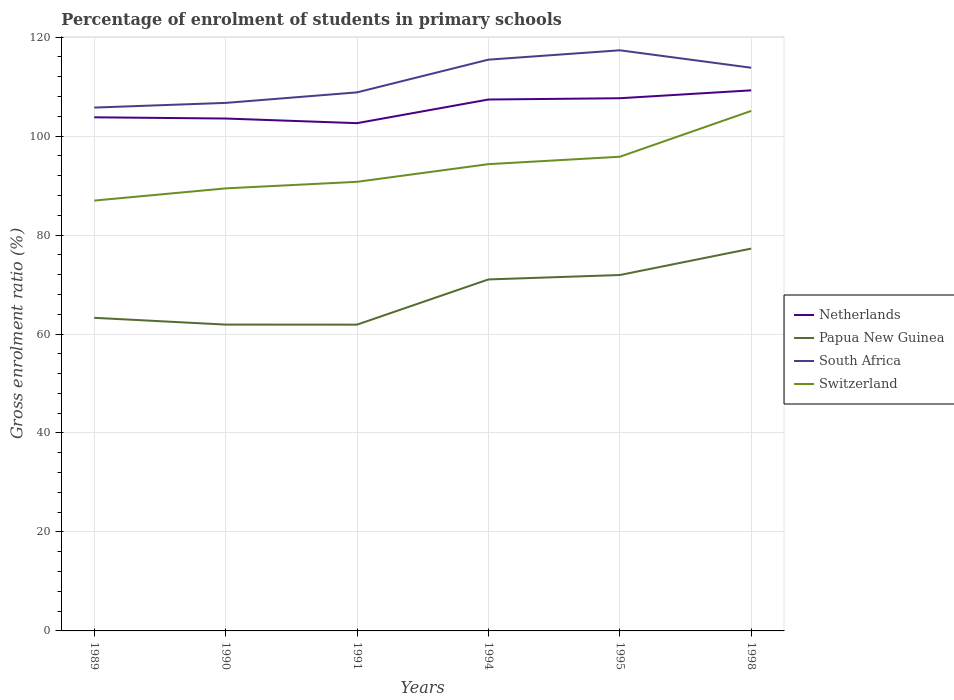How many different coloured lines are there?
Keep it short and to the point. 4. Is the number of lines equal to the number of legend labels?
Offer a very short reply. Yes. Across all years, what is the maximum percentage of students enrolled in primary schools in Switzerland?
Provide a short and direct response. 86.97. What is the total percentage of students enrolled in primary schools in Netherlands in the graph?
Ensure brevity in your answer.  0.25. What is the difference between the highest and the second highest percentage of students enrolled in primary schools in South Africa?
Make the answer very short. 11.58. What is the difference between the highest and the lowest percentage of students enrolled in primary schools in Switzerland?
Make the answer very short. 3. How many years are there in the graph?
Give a very brief answer. 6. Where does the legend appear in the graph?
Provide a short and direct response. Center right. How many legend labels are there?
Ensure brevity in your answer.  4. What is the title of the graph?
Your answer should be compact. Percentage of enrolment of students in primary schools. Does "Netherlands" appear as one of the legend labels in the graph?
Give a very brief answer. Yes. What is the label or title of the X-axis?
Keep it short and to the point. Years. What is the Gross enrolment ratio (%) of Netherlands in 1989?
Give a very brief answer. 103.8. What is the Gross enrolment ratio (%) of Papua New Guinea in 1989?
Offer a terse response. 63.28. What is the Gross enrolment ratio (%) in South Africa in 1989?
Make the answer very short. 105.76. What is the Gross enrolment ratio (%) in Switzerland in 1989?
Your answer should be compact. 86.97. What is the Gross enrolment ratio (%) of Netherlands in 1990?
Give a very brief answer. 103.55. What is the Gross enrolment ratio (%) in Papua New Guinea in 1990?
Your answer should be very brief. 61.91. What is the Gross enrolment ratio (%) of South Africa in 1990?
Provide a succinct answer. 106.71. What is the Gross enrolment ratio (%) in Switzerland in 1990?
Your response must be concise. 89.43. What is the Gross enrolment ratio (%) in Netherlands in 1991?
Provide a short and direct response. 102.61. What is the Gross enrolment ratio (%) of Papua New Guinea in 1991?
Provide a short and direct response. 61.9. What is the Gross enrolment ratio (%) in South Africa in 1991?
Provide a succinct answer. 108.83. What is the Gross enrolment ratio (%) of Switzerland in 1991?
Provide a short and direct response. 90.76. What is the Gross enrolment ratio (%) in Netherlands in 1994?
Your answer should be compact. 107.39. What is the Gross enrolment ratio (%) in Papua New Guinea in 1994?
Offer a terse response. 71.03. What is the Gross enrolment ratio (%) in South Africa in 1994?
Ensure brevity in your answer.  115.45. What is the Gross enrolment ratio (%) of Switzerland in 1994?
Your answer should be very brief. 94.33. What is the Gross enrolment ratio (%) in Netherlands in 1995?
Provide a succinct answer. 107.65. What is the Gross enrolment ratio (%) of Papua New Guinea in 1995?
Give a very brief answer. 71.92. What is the Gross enrolment ratio (%) in South Africa in 1995?
Provide a succinct answer. 117.34. What is the Gross enrolment ratio (%) of Switzerland in 1995?
Provide a short and direct response. 95.83. What is the Gross enrolment ratio (%) in Netherlands in 1998?
Provide a short and direct response. 109.25. What is the Gross enrolment ratio (%) in Papua New Guinea in 1998?
Offer a terse response. 77.26. What is the Gross enrolment ratio (%) in South Africa in 1998?
Keep it short and to the point. 113.82. What is the Gross enrolment ratio (%) of Switzerland in 1998?
Your answer should be very brief. 105.09. Across all years, what is the maximum Gross enrolment ratio (%) of Netherlands?
Make the answer very short. 109.25. Across all years, what is the maximum Gross enrolment ratio (%) in Papua New Guinea?
Provide a short and direct response. 77.26. Across all years, what is the maximum Gross enrolment ratio (%) in South Africa?
Your answer should be very brief. 117.34. Across all years, what is the maximum Gross enrolment ratio (%) of Switzerland?
Offer a terse response. 105.09. Across all years, what is the minimum Gross enrolment ratio (%) in Netherlands?
Ensure brevity in your answer.  102.61. Across all years, what is the minimum Gross enrolment ratio (%) in Papua New Guinea?
Your answer should be very brief. 61.9. Across all years, what is the minimum Gross enrolment ratio (%) in South Africa?
Offer a very short reply. 105.76. Across all years, what is the minimum Gross enrolment ratio (%) in Switzerland?
Make the answer very short. 86.97. What is the total Gross enrolment ratio (%) in Netherlands in the graph?
Provide a short and direct response. 634.25. What is the total Gross enrolment ratio (%) of Papua New Guinea in the graph?
Your response must be concise. 407.3. What is the total Gross enrolment ratio (%) in South Africa in the graph?
Offer a very short reply. 667.91. What is the total Gross enrolment ratio (%) of Switzerland in the graph?
Give a very brief answer. 562.41. What is the difference between the Gross enrolment ratio (%) of Netherlands in 1989 and that in 1990?
Keep it short and to the point. 0.25. What is the difference between the Gross enrolment ratio (%) in Papua New Guinea in 1989 and that in 1990?
Offer a very short reply. 1.37. What is the difference between the Gross enrolment ratio (%) of South Africa in 1989 and that in 1990?
Your answer should be very brief. -0.94. What is the difference between the Gross enrolment ratio (%) of Switzerland in 1989 and that in 1990?
Offer a very short reply. -2.47. What is the difference between the Gross enrolment ratio (%) of Netherlands in 1989 and that in 1991?
Your answer should be very brief. 1.18. What is the difference between the Gross enrolment ratio (%) in Papua New Guinea in 1989 and that in 1991?
Provide a short and direct response. 1.38. What is the difference between the Gross enrolment ratio (%) of South Africa in 1989 and that in 1991?
Your response must be concise. -3.07. What is the difference between the Gross enrolment ratio (%) in Switzerland in 1989 and that in 1991?
Your answer should be compact. -3.79. What is the difference between the Gross enrolment ratio (%) of Netherlands in 1989 and that in 1994?
Provide a succinct answer. -3.6. What is the difference between the Gross enrolment ratio (%) of Papua New Guinea in 1989 and that in 1994?
Offer a very short reply. -7.76. What is the difference between the Gross enrolment ratio (%) in South Africa in 1989 and that in 1994?
Offer a very short reply. -9.68. What is the difference between the Gross enrolment ratio (%) of Switzerland in 1989 and that in 1994?
Your response must be concise. -7.36. What is the difference between the Gross enrolment ratio (%) in Netherlands in 1989 and that in 1995?
Offer a very short reply. -3.85. What is the difference between the Gross enrolment ratio (%) of Papua New Guinea in 1989 and that in 1995?
Ensure brevity in your answer.  -8.65. What is the difference between the Gross enrolment ratio (%) of South Africa in 1989 and that in 1995?
Keep it short and to the point. -11.58. What is the difference between the Gross enrolment ratio (%) of Switzerland in 1989 and that in 1995?
Provide a short and direct response. -8.86. What is the difference between the Gross enrolment ratio (%) in Netherlands in 1989 and that in 1998?
Make the answer very short. -5.45. What is the difference between the Gross enrolment ratio (%) of Papua New Guinea in 1989 and that in 1998?
Provide a short and direct response. -13.99. What is the difference between the Gross enrolment ratio (%) of South Africa in 1989 and that in 1998?
Keep it short and to the point. -8.05. What is the difference between the Gross enrolment ratio (%) in Switzerland in 1989 and that in 1998?
Keep it short and to the point. -18.12. What is the difference between the Gross enrolment ratio (%) of Netherlands in 1990 and that in 1991?
Make the answer very short. 0.93. What is the difference between the Gross enrolment ratio (%) of Papua New Guinea in 1990 and that in 1991?
Make the answer very short. 0.01. What is the difference between the Gross enrolment ratio (%) in South Africa in 1990 and that in 1991?
Make the answer very short. -2.13. What is the difference between the Gross enrolment ratio (%) of Switzerland in 1990 and that in 1991?
Offer a very short reply. -1.33. What is the difference between the Gross enrolment ratio (%) of Netherlands in 1990 and that in 1994?
Keep it short and to the point. -3.85. What is the difference between the Gross enrolment ratio (%) in Papua New Guinea in 1990 and that in 1994?
Offer a very short reply. -9.13. What is the difference between the Gross enrolment ratio (%) of South Africa in 1990 and that in 1994?
Provide a short and direct response. -8.74. What is the difference between the Gross enrolment ratio (%) in Switzerland in 1990 and that in 1994?
Offer a terse response. -4.9. What is the difference between the Gross enrolment ratio (%) in Netherlands in 1990 and that in 1995?
Keep it short and to the point. -4.1. What is the difference between the Gross enrolment ratio (%) of Papua New Guinea in 1990 and that in 1995?
Provide a succinct answer. -10.02. What is the difference between the Gross enrolment ratio (%) of South Africa in 1990 and that in 1995?
Offer a very short reply. -10.63. What is the difference between the Gross enrolment ratio (%) in Switzerland in 1990 and that in 1995?
Your response must be concise. -6.39. What is the difference between the Gross enrolment ratio (%) in Netherlands in 1990 and that in 1998?
Make the answer very short. -5.7. What is the difference between the Gross enrolment ratio (%) in Papua New Guinea in 1990 and that in 1998?
Your answer should be compact. -15.36. What is the difference between the Gross enrolment ratio (%) in South Africa in 1990 and that in 1998?
Offer a terse response. -7.11. What is the difference between the Gross enrolment ratio (%) in Switzerland in 1990 and that in 1998?
Your answer should be very brief. -15.65. What is the difference between the Gross enrolment ratio (%) of Netherlands in 1991 and that in 1994?
Make the answer very short. -4.78. What is the difference between the Gross enrolment ratio (%) in Papua New Guinea in 1991 and that in 1994?
Give a very brief answer. -9.14. What is the difference between the Gross enrolment ratio (%) in South Africa in 1991 and that in 1994?
Your answer should be compact. -6.61. What is the difference between the Gross enrolment ratio (%) in Switzerland in 1991 and that in 1994?
Provide a succinct answer. -3.57. What is the difference between the Gross enrolment ratio (%) of Netherlands in 1991 and that in 1995?
Provide a succinct answer. -5.04. What is the difference between the Gross enrolment ratio (%) in Papua New Guinea in 1991 and that in 1995?
Make the answer very short. -10.03. What is the difference between the Gross enrolment ratio (%) in South Africa in 1991 and that in 1995?
Keep it short and to the point. -8.51. What is the difference between the Gross enrolment ratio (%) of Switzerland in 1991 and that in 1995?
Offer a very short reply. -5.06. What is the difference between the Gross enrolment ratio (%) of Netherlands in 1991 and that in 1998?
Your answer should be compact. -6.63. What is the difference between the Gross enrolment ratio (%) of Papua New Guinea in 1991 and that in 1998?
Ensure brevity in your answer.  -15.37. What is the difference between the Gross enrolment ratio (%) of South Africa in 1991 and that in 1998?
Provide a succinct answer. -4.98. What is the difference between the Gross enrolment ratio (%) of Switzerland in 1991 and that in 1998?
Make the answer very short. -14.33. What is the difference between the Gross enrolment ratio (%) in Netherlands in 1994 and that in 1995?
Give a very brief answer. -0.26. What is the difference between the Gross enrolment ratio (%) in Papua New Guinea in 1994 and that in 1995?
Make the answer very short. -0.89. What is the difference between the Gross enrolment ratio (%) of South Africa in 1994 and that in 1995?
Your answer should be very brief. -1.89. What is the difference between the Gross enrolment ratio (%) of Switzerland in 1994 and that in 1995?
Offer a very short reply. -1.49. What is the difference between the Gross enrolment ratio (%) of Netherlands in 1994 and that in 1998?
Ensure brevity in your answer.  -1.85. What is the difference between the Gross enrolment ratio (%) of Papua New Guinea in 1994 and that in 1998?
Provide a succinct answer. -6.23. What is the difference between the Gross enrolment ratio (%) of South Africa in 1994 and that in 1998?
Give a very brief answer. 1.63. What is the difference between the Gross enrolment ratio (%) in Switzerland in 1994 and that in 1998?
Your answer should be compact. -10.76. What is the difference between the Gross enrolment ratio (%) in Netherlands in 1995 and that in 1998?
Offer a very short reply. -1.59. What is the difference between the Gross enrolment ratio (%) of Papua New Guinea in 1995 and that in 1998?
Your response must be concise. -5.34. What is the difference between the Gross enrolment ratio (%) of South Africa in 1995 and that in 1998?
Ensure brevity in your answer.  3.52. What is the difference between the Gross enrolment ratio (%) in Switzerland in 1995 and that in 1998?
Ensure brevity in your answer.  -9.26. What is the difference between the Gross enrolment ratio (%) of Netherlands in 1989 and the Gross enrolment ratio (%) of Papua New Guinea in 1990?
Offer a terse response. 41.89. What is the difference between the Gross enrolment ratio (%) in Netherlands in 1989 and the Gross enrolment ratio (%) in South Africa in 1990?
Your response must be concise. -2.91. What is the difference between the Gross enrolment ratio (%) in Netherlands in 1989 and the Gross enrolment ratio (%) in Switzerland in 1990?
Offer a terse response. 14.36. What is the difference between the Gross enrolment ratio (%) of Papua New Guinea in 1989 and the Gross enrolment ratio (%) of South Africa in 1990?
Keep it short and to the point. -43.43. What is the difference between the Gross enrolment ratio (%) of Papua New Guinea in 1989 and the Gross enrolment ratio (%) of Switzerland in 1990?
Give a very brief answer. -26.16. What is the difference between the Gross enrolment ratio (%) of South Africa in 1989 and the Gross enrolment ratio (%) of Switzerland in 1990?
Your answer should be compact. 16.33. What is the difference between the Gross enrolment ratio (%) in Netherlands in 1989 and the Gross enrolment ratio (%) in Papua New Guinea in 1991?
Your answer should be compact. 41.9. What is the difference between the Gross enrolment ratio (%) of Netherlands in 1989 and the Gross enrolment ratio (%) of South Africa in 1991?
Your response must be concise. -5.04. What is the difference between the Gross enrolment ratio (%) of Netherlands in 1989 and the Gross enrolment ratio (%) of Switzerland in 1991?
Ensure brevity in your answer.  13.04. What is the difference between the Gross enrolment ratio (%) of Papua New Guinea in 1989 and the Gross enrolment ratio (%) of South Africa in 1991?
Keep it short and to the point. -45.56. What is the difference between the Gross enrolment ratio (%) of Papua New Guinea in 1989 and the Gross enrolment ratio (%) of Switzerland in 1991?
Provide a short and direct response. -27.48. What is the difference between the Gross enrolment ratio (%) in South Africa in 1989 and the Gross enrolment ratio (%) in Switzerland in 1991?
Offer a very short reply. 15. What is the difference between the Gross enrolment ratio (%) in Netherlands in 1989 and the Gross enrolment ratio (%) in Papua New Guinea in 1994?
Give a very brief answer. 32.76. What is the difference between the Gross enrolment ratio (%) of Netherlands in 1989 and the Gross enrolment ratio (%) of South Africa in 1994?
Your response must be concise. -11.65. What is the difference between the Gross enrolment ratio (%) in Netherlands in 1989 and the Gross enrolment ratio (%) in Switzerland in 1994?
Ensure brevity in your answer.  9.47. What is the difference between the Gross enrolment ratio (%) in Papua New Guinea in 1989 and the Gross enrolment ratio (%) in South Africa in 1994?
Provide a succinct answer. -52.17. What is the difference between the Gross enrolment ratio (%) in Papua New Guinea in 1989 and the Gross enrolment ratio (%) in Switzerland in 1994?
Provide a succinct answer. -31.05. What is the difference between the Gross enrolment ratio (%) of South Africa in 1989 and the Gross enrolment ratio (%) of Switzerland in 1994?
Provide a short and direct response. 11.43. What is the difference between the Gross enrolment ratio (%) of Netherlands in 1989 and the Gross enrolment ratio (%) of Papua New Guinea in 1995?
Your answer should be very brief. 31.87. What is the difference between the Gross enrolment ratio (%) in Netherlands in 1989 and the Gross enrolment ratio (%) in South Africa in 1995?
Ensure brevity in your answer.  -13.54. What is the difference between the Gross enrolment ratio (%) in Netherlands in 1989 and the Gross enrolment ratio (%) in Switzerland in 1995?
Provide a succinct answer. 7.97. What is the difference between the Gross enrolment ratio (%) in Papua New Guinea in 1989 and the Gross enrolment ratio (%) in South Africa in 1995?
Offer a terse response. -54.06. What is the difference between the Gross enrolment ratio (%) in Papua New Guinea in 1989 and the Gross enrolment ratio (%) in Switzerland in 1995?
Keep it short and to the point. -32.55. What is the difference between the Gross enrolment ratio (%) in South Africa in 1989 and the Gross enrolment ratio (%) in Switzerland in 1995?
Your answer should be very brief. 9.94. What is the difference between the Gross enrolment ratio (%) of Netherlands in 1989 and the Gross enrolment ratio (%) of Papua New Guinea in 1998?
Provide a succinct answer. 26.53. What is the difference between the Gross enrolment ratio (%) of Netherlands in 1989 and the Gross enrolment ratio (%) of South Africa in 1998?
Your answer should be very brief. -10.02. What is the difference between the Gross enrolment ratio (%) in Netherlands in 1989 and the Gross enrolment ratio (%) in Switzerland in 1998?
Your response must be concise. -1.29. What is the difference between the Gross enrolment ratio (%) of Papua New Guinea in 1989 and the Gross enrolment ratio (%) of South Africa in 1998?
Give a very brief answer. -50.54. What is the difference between the Gross enrolment ratio (%) of Papua New Guinea in 1989 and the Gross enrolment ratio (%) of Switzerland in 1998?
Your response must be concise. -41.81. What is the difference between the Gross enrolment ratio (%) of South Africa in 1989 and the Gross enrolment ratio (%) of Switzerland in 1998?
Ensure brevity in your answer.  0.68. What is the difference between the Gross enrolment ratio (%) in Netherlands in 1990 and the Gross enrolment ratio (%) in Papua New Guinea in 1991?
Your response must be concise. 41.65. What is the difference between the Gross enrolment ratio (%) in Netherlands in 1990 and the Gross enrolment ratio (%) in South Africa in 1991?
Offer a terse response. -5.29. What is the difference between the Gross enrolment ratio (%) of Netherlands in 1990 and the Gross enrolment ratio (%) of Switzerland in 1991?
Provide a short and direct response. 12.79. What is the difference between the Gross enrolment ratio (%) of Papua New Guinea in 1990 and the Gross enrolment ratio (%) of South Africa in 1991?
Ensure brevity in your answer.  -46.93. What is the difference between the Gross enrolment ratio (%) in Papua New Guinea in 1990 and the Gross enrolment ratio (%) in Switzerland in 1991?
Offer a terse response. -28.85. What is the difference between the Gross enrolment ratio (%) of South Africa in 1990 and the Gross enrolment ratio (%) of Switzerland in 1991?
Offer a terse response. 15.95. What is the difference between the Gross enrolment ratio (%) of Netherlands in 1990 and the Gross enrolment ratio (%) of Papua New Guinea in 1994?
Ensure brevity in your answer.  32.52. What is the difference between the Gross enrolment ratio (%) in Netherlands in 1990 and the Gross enrolment ratio (%) in South Africa in 1994?
Your response must be concise. -11.9. What is the difference between the Gross enrolment ratio (%) in Netherlands in 1990 and the Gross enrolment ratio (%) in Switzerland in 1994?
Make the answer very short. 9.22. What is the difference between the Gross enrolment ratio (%) in Papua New Guinea in 1990 and the Gross enrolment ratio (%) in South Africa in 1994?
Provide a short and direct response. -53.54. What is the difference between the Gross enrolment ratio (%) in Papua New Guinea in 1990 and the Gross enrolment ratio (%) in Switzerland in 1994?
Provide a succinct answer. -32.43. What is the difference between the Gross enrolment ratio (%) in South Africa in 1990 and the Gross enrolment ratio (%) in Switzerland in 1994?
Ensure brevity in your answer.  12.38. What is the difference between the Gross enrolment ratio (%) of Netherlands in 1990 and the Gross enrolment ratio (%) of Papua New Guinea in 1995?
Ensure brevity in your answer.  31.62. What is the difference between the Gross enrolment ratio (%) of Netherlands in 1990 and the Gross enrolment ratio (%) of South Africa in 1995?
Make the answer very short. -13.79. What is the difference between the Gross enrolment ratio (%) of Netherlands in 1990 and the Gross enrolment ratio (%) of Switzerland in 1995?
Keep it short and to the point. 7.72. What is the difference between the Gross enrolment ratio (%) of Papua New Guinea in 1990 and the Gross enrolment ratio (%) of South Africa in 1995?
Keep it short and to the point. -55.43. What is the difference between the Gross enrolment ratio (%) of Papua New Guinea in 1990 and the Gross enrolment ratio (%) of Switzerland in 1995?
Your answer should be compact. -33.92. What is the difference between the Gross enrolment ratio (%) in South Africa in 1990 and the Gross enrolment ratio (%) in Switzerland in 1995?
Your response must be concise. 10.88. What is the difference between the Gross enrolment ratio (%) in Netherlands in 1990 and the Gross enrolment ratio (%) in Papua New Guinea in 1998?
Offer a very short reply. 26.28. What is the difference between the Gross enrolment ratio (%) in Netherlands in 1990 and the Gross enrolment ratio (%) in South Africa in 1998?
Keep it short and to the point. -10.27. What is the difference between the Gross enrolment ratio (%) in Netherlands in 1990 and the Gross enrolment ratio (%) in Switzerland in 1998?
Make the answer very short. -1.54. What is the difference between the Gross enrolment ratio (%) in Papua New Guinea in 1990 and the Gross enrolment ratio (%) in South Africa in 1998?
Provide a short and direct response. -51.91. What is the difference between the Gross enrolment ratio (%) in Papua New Guinea in 1990 and the Gross enrolment ratio (%) in Switzerland in 1998?
Give a very brief answer. -43.18. What is the difference between the Gross enrolment ratio (%) in South Africa in 1990 and the Gross enrolment ratio (%) in Switzerland in 1998?
Keep it short and to the point. 1.62. What is the difference between the Gross enrolment ratio (%) in Netherlands in 1991 and the Gross enrolment ratio (%) in Papua New Guinea in 1994?
Ensure brevity in your answer.  31.58. What is the difference between the Gross enrolment ratio (%) of Netherlands in 1991 and the Gross enrolment ratio (%) of South Africa in 1994?
Your response must be concise. -12.83. What is the difference between the Gross enrolment ratio (%) in Netherlands in 1991 and the Gross enrolment ratio (%) in Switzerland in 1994?
Offer a very short reply. 8.28. What is the difference between the Gross enrolment ratio (%) of Papua New Guinea in 1991 and the Gross enrolment ratio (%) of South Africa in 1994?
Keep it short and to the point. -53.55. What is the difference between the Gross enrolment ratio (%) of Papua New Guinea in 1991 and the Gross enrolment ratio (%) of Switzerland in 1994?
Provide a succinct answer. -32.43. What is the difference between the Gross enrolment ratio (%) of South Africa in 1991 and the Gross enrolment ratio (%) of Switzerland in 1994?
Ensure brevity in your answer.  14.5. What is the difference between the Gross enrolment ratio (%) in Netherlands in 1991 and the Gross enrolment ratio (%) in Papua New Guinea in 1995?
Offer a terse response. 30.69. What is the difference between the Gross enrolment ratio (%) of Netherlands in 1991 and the Gross enrolment ratio (%) of South Africa in 1995?
Keep it short and to the point. -14.73. What is the difference between the Gross enrolment ratio (%) in Netherlands in 1991 and the Gross enrolment ratio (%) in Switzerland in 1995?
Your answer should be very brief. 6.79. What is the difference between the Gross enrolment ratio (%) in Papua New Guinea in 1991 and the Gross enrolment ratio (%) in South Africa in 1995?
Ensure brevity in your answer.  -55.44. What is the difference between the Gross enrolment ratio (%) in Papua New Guinea in 1991 and the Gross enrolment ratio (%) in Switzerland in 1995?
Make the answer very short. -33.93. What is the difference between the Gross enrolment ratio (%) in South Africa in 1991 and the Gross enrolment ratio (%) in Switzerland in 1995?
Keep it short and to the point. 13.01. What is the difference between the Gross enrolment ratio (%) in Netherlands in 1991 and the Gross enrolment ratio (%) in Papua New Guinea in 1998?
Keep it short and to the point. 25.35. What is the difference between the Gross enrolment ratio (%) of Netherlands in 1991 and the Gross enrolment ratio (%) of South Africa in 1998?
Make the answer very short. -11.2. What is the difference between the Gross enrolment ratio (%) of Netherlands in 1991 and the Gross enrolment ratio (%) of Switzerland in 1998?
Offer a very short reply. -2.47. What is the difference between the Gross enrolment ratio (%) of Papua New Guinea in 1991 and the Gross enrolment ratio (%) of South Africa in 1998?
Your answer should be compact. -51.92. What is the difference between the Gross enrolment ratio (%) of Papua New Guinea in 1991 and the Gross enrolment ratio (%) of Switzerland in 1998?
Give a very brief answer. -43.19. What is the difference between the Gross enrolment ratio (%) of South Africa in 1991 and the Gross enrolment ratio (%) of Switzerland in 1998?
Provide a short and direct response. 3.75. What is the difference between the Gross enrolment ratio (%) of Netherlands in 1994 and the Gross enrolment ratio (%) of Papua New Guinea in 1995?
Provide a short and direct response. 35.47. What is the difference between the Gross enrolment ratio (%) of Netherlands in 1994 and the Gross enrolment ratio (%) of South Africa in 1995?
Your answer should be compact. -9.95. What is the difference between the Gross enrolment ratio (%) of Netherlands in 1994 and the Gross enrolment ratio (%) of Switzerland in 1995?
Offer a terse response. 11.57. What is the difference between the Gross enrolment ratio (%) in Papua New Guinea in 1994 and the Gross enrolment ratio (%) in South Africa in 1995?
Your answer should be very brief. -46.31. What is the difference between the Gross enrolment ratio (%) in Papua New Guinea in 1994 and the Gross enrolment ratio (%) in Switzerland in 1995?
Ensure brevity in your answer.  -24.79. What is the difference between the Gross enrolment ratio (%) in South Africa in 1994 and the Gross enrolment ratio (%) in Switzerland in 1995?
Your response must be concise. 19.62. What is the difference between the Gross enrolment ratio (%) of Netherlands in 1994 and the Gross enrolment ratio (%) of Papua New Guinea in 1998?
Give a very brief answer. 30.13. What is the difference between the Gross enrolment ratio (%) in Netherlands in 1994 and the Gross enrolment ratio (%) in South Africa in 1998?
Give a very brief answer. -6.42. What is the difference between the Gross enrolment ratio (%) of Netherlands in 1994 and the Gross enrolment ratio (%) of Switzerland in 1998?
Your answer should be compact. 2.31. What is the difference between the Gross enrolment ratio (%) in Papua New Guinea in 1994 and the Gross enrolment ratio (%) in South Africa in 1998?
Your response must be concise. -42.78. What is the difference between the Gross enrolment ratio (%) of Papua New Guinea in 1994 and the Gross enrolment ratio (%) of Switzerland in 1998?
Give a very brief answer. -34.05. What is the difference between the Gross enrolment ratio (%) of South Africa in 1994 and the Gross enrolment ratio (%) of Switzerland in 1998?
Keep it short and to the point. 10.36. What is the difference between the Gross enrolment ratio (%) in Netherlands in 1995 and the Gross enrolment ratio (%) in Papua New Guinea in 1998?
Provide a succinct answer. 30.39. What is the difference between the Gross enrolment ratio (%) of Netherlands in 1995 and the Gross enrolment ratio (%) of South Africa in 1998?
Ensure brevity in your answer.  -6.16. What is the difference between the Gross enrolment ratio (%) in Netherlands in 1995 and the Gross enrolment ratio (%) in Switzerland in 1998?
Your answer should be very brief. 2.57. What is the difference between the Gross enrolment ratio (%) in Papua New Guinea in 1995 and the Gross enrolment ratio (%) in South Africa in 1998?
Keep it short and to the point. -41.89. What is the difference between the Gross enrolment ratio (%) in Papua New Guinea in 1995 and the Gross enrolment ratio (%) in Switzerland in 1998?
Ensure brevity in your answer.  -33.16. What is the difference between the Gross enrolment ratio (%) in South Africa in 1995 and the Gross enrolment ratio (%) in Switzerland in 1998?
Ensure brevity in your answer.  12.25. What is the average Gross enrolment ratio (%) of Netherlands per year?
Provide a succinct answer. 105.71. What is the average Gross enrolment ratio (%) in Papua New Guinea per year?
Offer a very short reply. 67.88. What is the average Gross enrolment ratio (%) in South Africa per year?
Provide a succinct answer. 111.32. What is the average Gross enrolment ratio (%) in Switzerland per year?
Offer a very short reply. 93.73. In the year 1989, what is the difference between the Gross enrolment ratio (%) in Netherlands and Gross enrolment ratio (%) in Papua New Guinea?
Provide a short and direct response. 40.52. In the year 1989, what is the difference between the Gross enrolment ratio (%) of Netherlands and Gross enrolment ratio (%) of South Africa?
Give a very brief answer. -1.97. In the year 1989, what is the difference between the Gross enrolment ratio (%) of Netherlands and Gross enrolment ratio (%) of Switzerland?
Make the answer very short. 16.83. In the year 1989, what is the difference between the Gross enrolment ratio (%) of Papua New Guinea and Gross enrolment ratio (%) of South Africa?
Your answer should be very brief. -42.49. In the year 1989, what is the difference between the Gross enrolment ratio (%) of Papua New Guinea and Gross enrolment ratio (%) of Switzerland?
Offer a terse response. -23.69. In the year 1989, what is the difference between the Gross enrolment ratio (%) of South Africa and Gross enrolment ratio (%) of Switzerland?
Offer a very short reply. 18.8. In the year 1990, what is the difference between the Gross enrolment ratio (%) of Netherlands and Gross enrolment ratio (%) of Papua New Guinea?
Offer a very short reply. 41.64. In the year 1990, what is the difference between the Gross enrolment ratio (%) in Netherlands and Gross enrolment ratio (%) in South Africa?
Offer a terse response. -3.16. In the year 1990, what is the difference between the Gross enrolment ratio (%) in Netherlands and Gross enrolment ratio (%) in Switzerland?
Offer a terse response. 14.11. In the year 1990, what is the difference between the Gross enrolment ratio (%) of Papua New Guinea and Gross enrolment ratio (%) of South Africa?
Keep it short and to the point. -44.8. In the year 1990, what is the difference between the Gross enrolment ratio (%) in Papua New Guinea and Gross enrolment ratio (%) in Switzerland?
Make the answer very short. -27.53. In the year 1990, what is the difference between the Gross enrolment ratio (%) of South Africa and Gross enrolment ratio (%) of Switzerland?
Provide a succinct answer. 17.28. In the year 1991, what is the difference between the Gross enrolment ratio (%) of Netherlands and Gross enrolment ratio (%) of Papua New Guinea?
Your response must be concise. 40.72. In the year 1991, what is the difference between the Gross enrolment ratio (%) of Netherlands and Gross enrolment ratio (%) of South Africa?
Offer a terse response. -6.22. In the year 1991, what is the difference between the Gross enrolment ratio (%) of Netherlands and Gross enrolment ratio (%) of Switzerland?
Your response must be concise. 11.85. In the year 1991, what is the difference between the Gross enrolment ratio (%) in Papua New Guinea and Gross enrolment ratio (%) in South Africa?
Provide a succinct answer. -46.94. In the year 1991, what is the difference between the Gross enrolment ratio (%) in Papua New Guinea and Gross enrolment ratio (%) in Switzerland?
Offer a very short reply. -28.86. In the year 1991, what is the difference between the Gross enrolment ratio (%) of South Africa and Gross enrolment ratio (%) of Switzerland?
Offer a terse response. 18.07. In the year 1994, what is the difference between the Gross enrolment ratio (%) in Netherlands and Gross enrolment ratio (%) in Papua New Guinea?
Give a very brief answer. 36.36. In the year 1994, what is the difference between the Gross enrolment ratio (%) of Netherlands and Gross enrolment ratio (%) of South Africa?
Make the answer very short. -8.05. In the year 1994, what is the difference between the Gross enrolment ratio (%) in Netherlands and Gross enrolment ratio (%) in Switzerland?
Offer a very short reply. 13.06. In the year 1994, what is the difference between the Gross enrolment ratio (%) of Papua New Guinea and Gross enrolment ratio (%) of South Africa?
Provide a short and direct response. -44.41. In the year 1994, what is the difference between the Gross enrolment ratio (%) in Papua New Guinea and Gross enrolment ratio (%) in Switzerland?
Offer a very short reply. -23.3. In the year 1994, what is the difference between the Gross enrolment ratio (%) of South Africa and Gross enrolment ratio (%) of Switzerland?
Your answer should be very brief. 21.12. In the year 1995, what is the difference between the Gross enrolment ratio (%) in Netherlands and Gross enrolment ratio (%) in Papua New Guinea?
Provide a succinct answer. 35.73. In the year 1995, what is the difference between the Gross enrolment ratio (%) in Netherlands and Gross enrolment ratio (%) in South Africa?
Provide a succinct answer. -9.69. In the year 1995, what is the difference between the Gross enrolment ratio (%) in Netherlands and Gross enrolment ratio (%) in Switzerland?
Provide a short and direct response. 11.83. In the year 1995, what is the difference between the Gross enrolment ratio (%) of Papua New Guinea and Gross enrolment ratio (%) of South Africa?
Provide a short and direct response. -45.42. In the year 1995, what is the difference between the Gross enrolment ratio (%) in Papua New Guinea and Gross enrolment ratio (%) in Switzerland?
Your answer should be very brief. -23.9. In the year 1995, what is the difference between the Gross enrolment ratio (%) in South Africa and Gross enrolment ratio (%) in Switzerland?
Provide a short and direct response. 21.51. In the year 1998, what is the difference between the Gross enrolment ratio (%) in Netherlands and Gross enrolment ratio (%) in Papua New Guinea?
Your answer should be very brief. 31.98. In the year 1998, what is the difference between the Gross enrolment ratio (%) of Netherlands and Gross enrolment ratio (%) of South Africa?
Give a very brief answer. -4.57. In the year 1998, what is the difference between the Gross enrolment ratio (%) of Netherlands and Gross enrolment ratio (%) of Switzerland?
Provide a succinct answer. 4.16. In the year 1998, what is the difference between the Gross enrolment ratio (%) in Papua New Guinea and Gross enrolment ratio (%) in South Africa?
Offer a terse response. -36.55. In the year 1998, what is the difference between the Gross enrolment ratio (%) of Papua New Guinea and Gross enrolment ratio (%) of Switzerland?
Keep it short and to the point. -27.82. In the year 1998, what is the difference between the Gross enrolment ratio (%) in South Africa and Gross enrolment ratio (%) in Switzerland?
Offer a terse response. 8.73. What is the ratio of the Gross enrolment ratio (%) in Papua New Guinea in 1989 to that in 1990?
Make the answer very short. 1.02. What is the ratio of the Gross enrolment ratio (%) of Switzerland in 1989 to that in 1990?
Give a very brief answer. 0.97. What is the ratio of the Gross enrolment ratio (%) in Netherlands in 1989 to that in 1991?
Your answer should be compact. 1.01. What is the ratio of the Gross enrolment ratio (%) of Papua New Guinea in 1989 to that in 1991?
Provide a short and direct response. 1.02. What is the ratio of the Gross enrolment ratio (%) of South Africa in 1989 to that in 1991?
Your response must be concise. 0.97. What is the ratio of the Gross enrolment ratio (%) in Switzerland in 1989 to that in 1991?
Give a very brief answer. 0.96. What is the ratio of the Gross enrolment ratio (%) in Netherlands in 1989 to that in 1994?
Provide a succinct answer. 0.97. What is the ratio of the Gross enrolment ratio (%) in Papua New Guinea in 1989 to that in 1994?
Keep it short and to the point. 0.89. What is the ratio of the Gross enrolment ratio (%) in South Africa in 1989 to that in 1994?
Your response must be concise. 0.92. What is the ratio of the Gross enrolment ratio (%) in Switzerland in 1989 to that in 1994?
Your answer should be compact. 0.92. What is the ratio of the Gross enrolment ratio (%) of Netherlands in 1989 to that in 1995?
Offer a terse response. 0.96. What is the ratio of the Gross enrolment ratio (%) in Papua New Guinea in 1989 to that in 1995?
Provide a succinct answer. 0.88. What is the ratio of the Gross enrolment ratio (%) of South Africa in 1989 to that in 1995?
Make the answer very short. 0.9. What is the ratio of the Gross enrolment ratio (%) of Switzerland in 1989 to that in 1995?
Your answer should be compact. 0.91. What is the ratio of the Gross enrolment ratio (%) of Netherlands in 1989 to that in 1998?
Your response must be concise. 0.95. What is the ratio of the Gross enrolment ratio (%) in Papua New Guinea in 1989 to that in 1998?
Your response must be concise. 0.82. What is the ratio of the Gross enrolment ratio (%) of South Africa in 1989 to that in 1998?
Your answer should be compact. 0.93. What is the ratio of the Gross enrolment ratio (%) in Switzerland in 1989 to that in 1998?
Offer a very short reply. 0.83. What is the ratio of the Gross enrolment ratio (%) of Netherlands in 1990 to that in 1991?
Provide a short and direct response. 1.01. What is the ratio of the Gross enrolment ratio (%) of Papua New Guinea in 1990 to that in 1991?
Keep it short and to the point. 1. What is the ratio of the Gross enrolment ratio (%) of South Africa in 1990 to that in 1991?
Provide a succinct answer. 0.98. What is the ratio of the Gross enrolment ratio (%) of Switzerland in 1990 to that in 1991?
Give a very brief answer. 0.99. What is the ratio of the Gross enrolment ratio (%) in Netherlands in 1990 to that in 1994?
Ensure brevity in your answer.  0.96. What is the ratio of the Gross enrolment ratio (%) in Papua New Guinea in 1990 to that in 1994?
Provide a short and direct response. 0.87. What is the ratio of the Gross enrolment ratio (%) in South Africa in 1990 to that in 1994?
Provide a succinct answer. 0.92. What is the ratio of the Gross enrolment ratio (%) in Switzerland in 1990 to that in 1994?
Keep it short and to the point. 0.95. What is the ratio of the Gross enrolment ratio (%) in Netherlands in 1990 to that in 1995?
Ensure brevity in your answer.  0.96. What is the ratio of the Gross enrolment ratio (%) of Papua New Guinea in 1990 to that in 1995?
Ensure brevity in your answer.  0.86. What is the ratio of the Gross enrolment ratio (%) of South Africa in 1990 to that in 1995?
Provide a succinct answer. 0.91. What is the ratio of the Gross enrolment ratio (%) of Netherlands in 1990 to that in 1998?
Keep it short and to the point. 0.95. What is the ratio of the Gross enrolment ratio (%) of Papua New Guinea in 1990 to that in 1998?
Offer a terse response. 0.8. What is the ratio of the Gross enrolment ratio (%) of South Africa in 1990 to that in 1998?
Your response must be concise. 0.94. What is the ratio of the Gross enrolment ratio (%) in Switzerland in 1990 to that in 1998?
Keep it short and to the point. 0.85. What is the ratio of the Gross enrolment ratio (%) of Netherlands in 1991 to that in 1994?
Provide a short and direct response. 0.96. What is the ratio of the Gross enrolment ratio (%) of Papua New Guinea in 1991 to that in 1994?
Give a very brief answer. 0.87. What is the ratio of the Gross enrolment ratio (%) of South Africa in 1991 to that in 1994?
Provide a succinct answer. 0.94. What is the ratio of the Gross enrolment ratio (%) in Switzerland in 1991 to that in 1994?
Make the answer very short. 0.96. What is the ratio of the Gross enrolment ratio (%) of Netherlands in 1991 to that in 1995?
Provide a short and direct response. 0.95. What is the ratio of the Gross enrolment ratio (%) in Papua New Guinea in 1991 to that in 1995?
Keep it short and to the point. 0.86. What is the ratio of the Gross enrolment ratio (%) in South Africa in 1991 to that in 1995?
Your response must be concise. 0.93. What is the ratio of the Gross enrolment ratio (%) of Switzerland in 1991 to that in 1995?
Your response must be concise. 0.95. What is the ratio of the Gross enrolment ratio (%) of Netherlands in 1991 to that in 1998?
Ensure brevity in your answer.  0.94. What is the ratio of the Gross enrolment ratio (%) of Papua New Guinea in 1991 to that in 1998?
Your response must be concise. 0.8. What is the ratio of the Gross enrolment ratio (%) in South Africa in 1991 to that in 1998?
Ensure brevity in your answer.  0.96. What is the ratio of the Gross enrolment ratio (%) in Switzerland in 1991 to that in 1998?
Your response must be concise. 0.86. What is the ratio of the Gross enrolment ratio (%) of Papua New Guinea in 1994 to that in 1995?
Offer a terse response. 0.99. What is the ratio of the Gross enrolment ratio (%) of South Africa in 1994 to that in 1995?
Keep it short and to the point. 0.98. What is the ratio of the Gross enrolment ratio (%) in Switzerland in 1994 to that in 1995?
Ensure brevity in your answer.  0.98. What is the ratio of the Gross enrolment ratio (%) in Netherlands in 1994 to that in 1998?
Provide a short and direct response. 0.98. What is the ratio of the Gross enrolment ratio (%) in Papua New Guinea in 1994 to that in 1998?
Your answer should be very brief. 0.92. What is the ratio of the Gross enrolment ratio (%) of South Africa in 1994 to that in 1998?
Provide a succinct answer. 1.01. What is the ratio of the Gross enrolment ratio (%) of Switzerland in 1994 to that in 1998?
Ensure brevity in your answer.  0.9. What is the ratio of the Gross enrolment ratio (%) in Netherlands in 1995 to that in 1998?
Ensure brevity in your answer.  0.99. What is the ratio of the Gross enrolment ratio (%) in Papua New Guinea in 1995 to that in 1998?
Keep it short and to the point. 0.93. What is the ratio of the Gross enrolment ratio (%) of South Africa in 1995 to that in 1998?
Your answer should be very brief. 1.03. What is the ratio of the Gross enrolment ratio (%) in Switzerland in 1995 to that in 1998?
Ensure brevity in your answer.  0.91. What is the difference between the highest and the second highest Gross enrolment ratio (%) in Netherlands?
Give a very brief answer. 1.59. What is the difference between the highest and the second highest Gross enrolment ratio (%) of Papua New Guinea?
Give a very brief answer. 5.34. What is the difference between the highest and the second highest Gross enrolment ratio (%) of South Africa?
Provide a short and direct response. 1.89. What is the difference between the highest and the second highest Gross enrolment ratio (%) in Switzerland?
Give a very brief answer. 9.26. What is the difference between the highest and the lowest Gross enrolment ratio (%) of Netherlands?
Offer a terse response. 6.63. What is the difference between the highest and the lowest Gross enrolment ratio (%) in Papua New Guinea?
Offer a very short reply. 15.37. What is the difference between the highest and the lowest Gross enrolment ratio (%) in South Africa?
Your answer should be compact. 11.58. What is the difference between the highest and the lowest Gross enrolment ratio (%) of Switzerland?
Your answer should be compact. 18.12. 